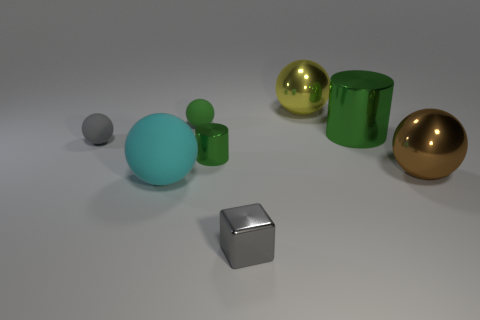Subtract all gray spheres. How many spheres are left? 4 Subtract all tiny matte spheres. How many spheres are left? 3 Add 1 green matte objects. How many objects exist? 9 Subtract all cubes. How many objects are left? 7 Subtract 1 balls. How many balls are left? 4 Subtract all cyan balls. Subtract all red cylinders. How many balls are left? 4 Subtract all yellow cylinders. How many cyan balls are left? 1 Subtract all large green metal cylinders. Subtract all green rubber spheres. How many objects are left? 6 Add 4 cyan objects. How many cyan objects are left? 5 Add 3 tiny green rubber things. How many tiny green rubber things exist? 4 